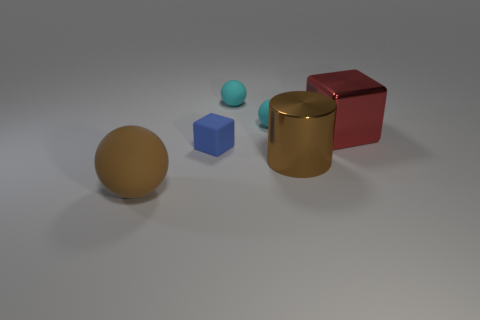Is there a red cube? yes 